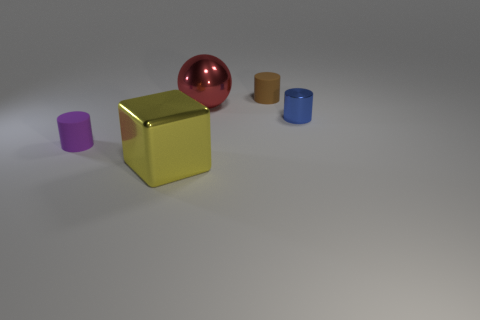What do you infer about the texture of the objects in the image? The textures of the objects are visually distinctive. The metal sphere and the yellow cube look smooth and likely have a slick, cold touch characteristic of polished metal. The matte purple cube appears to have a soft-touch finish, perhaps like a fine-grit sandblasted surface, which would likely feel slightly coarse to the touch. The rubber cylinders seem to have a smoother texture than the purple cube but not as polished as the metal objects, suggesting a typical rubber texture that's smooth with some resistance. 